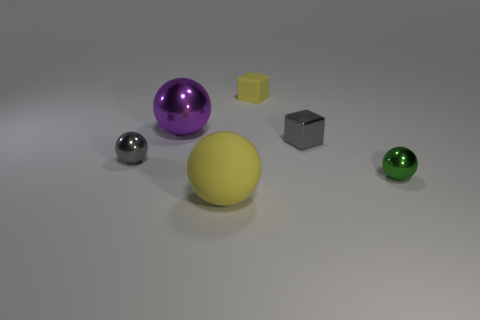Subtract all yellow spheres. How many spheres are left? 3 Add 2 yellow cubes. How many objects exist? 8 Subtract 2 balls. How many balls are left? 2 Subtract all purple balls. How many balls are left? 3 Subtract all blocks. How many objects are left? 4 Subtract all big yellow metallic things. Subtract all gray metal objects. How many objects are left? 4 Add 4 tiny shiny cubes. How many tiny shiny cubes are left? 5 Add 3 tiny gray balls. How many tiny gray balls exist? 4 Subtract 1 green spheres. How many objects are left? 5 Subtract all green spheres. Subtract all yellow blocks. How many spheres are left? 3 